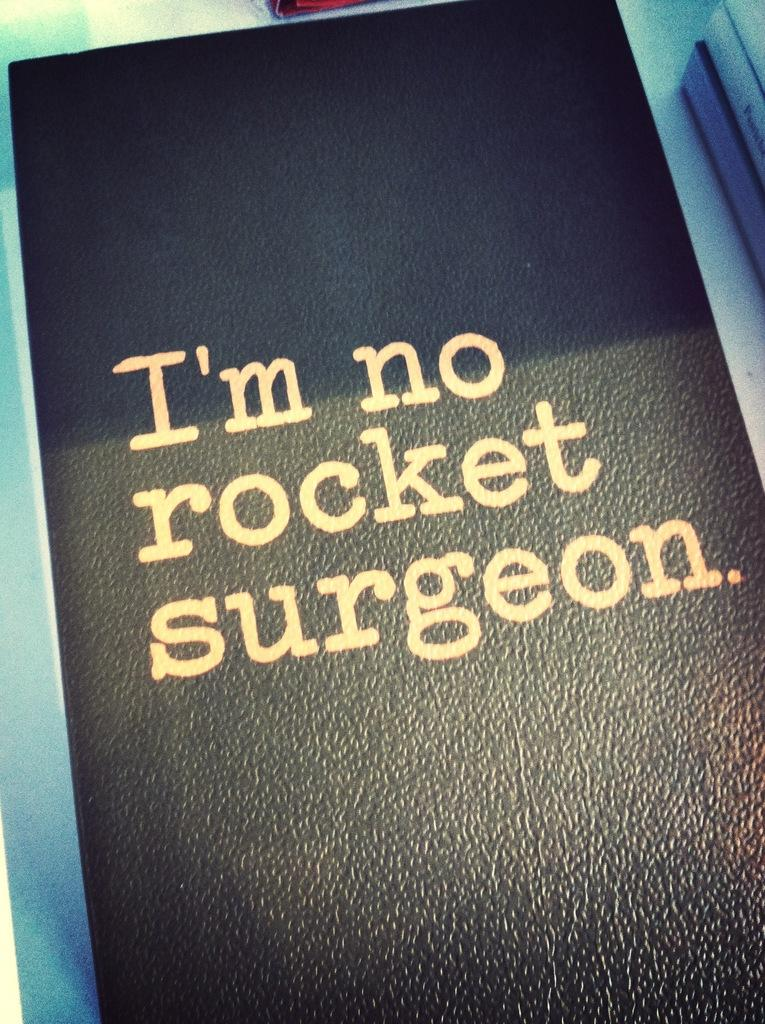<image>
Offer a succinct explanation of the picture presented. A leather bound book states I'm no rocket surgeon. 